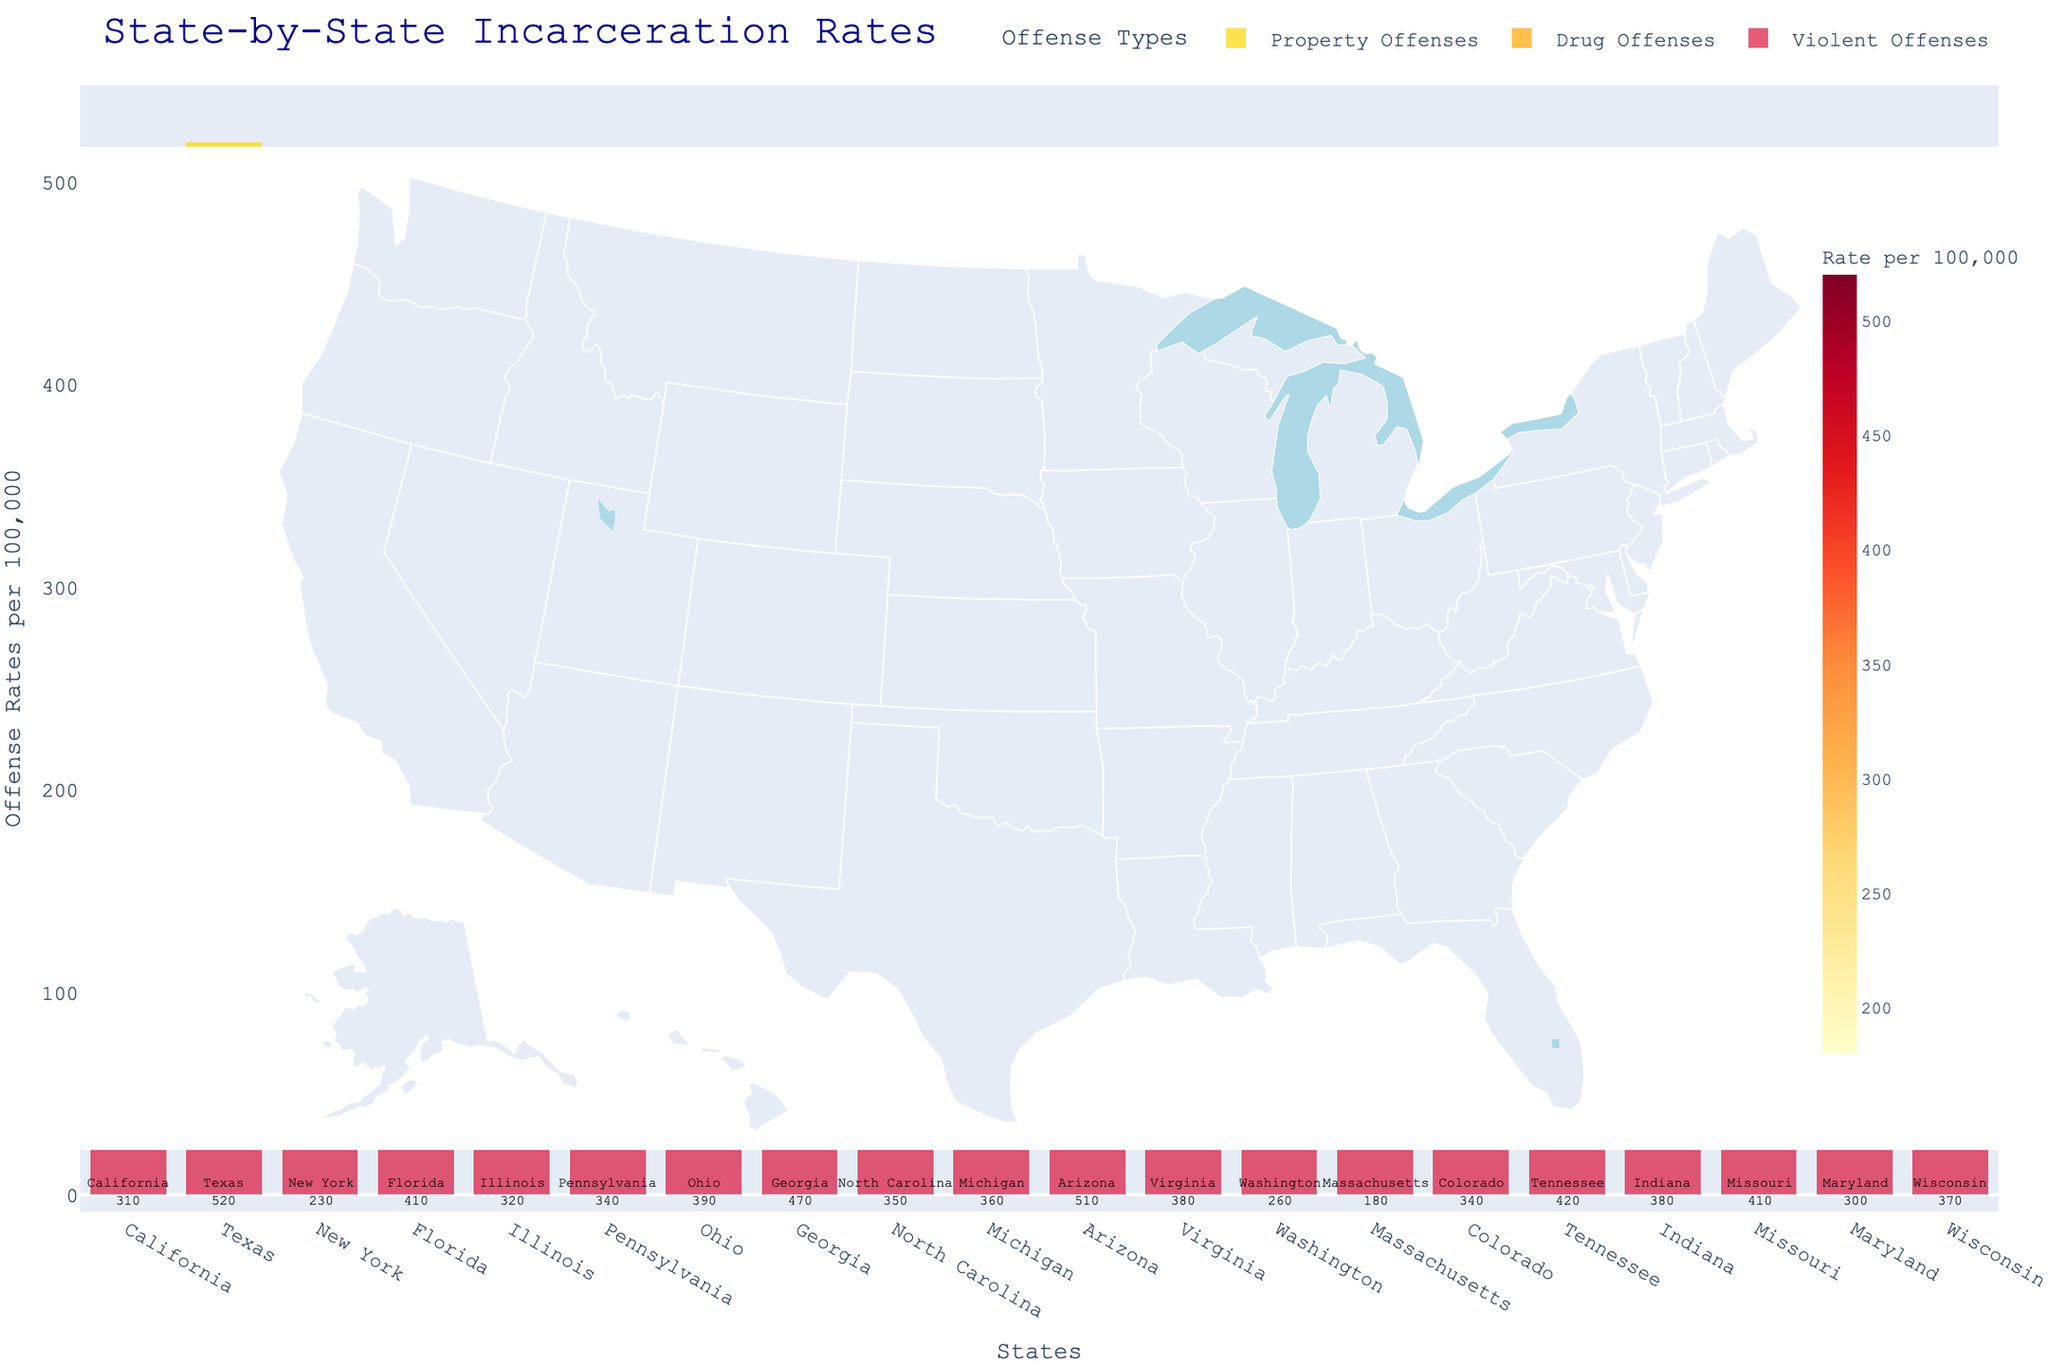What is the total incarceration rate for Texas? By viewing the figure, locate Texas and find the number associated with its total incarceration rate next to it.
Answer: 520 Which state has the lowest total incarceration rate? Scan through all the states listed in the figure and identify the one with the smallest number for total incarceration rate.
Answer: Massachusetts How much higher is the drug offense rate in Georgia compared to Massachusetts? Locate both Georgia and Massachusetts on the figure. Subtract the drug offense rate of Massachusetts (50) from that of Georgia (140).
Answer: 90 Which states have a total incarceration rate between 300 and 400? Identify states by examining their total incarceration rate figures and noting those that fall between 300 and 400.
Answer: California, Illinois, Pennsylvania, North Carolina, Michigan, Colorado, Virginia, Indiana, Maryland, Wisconsin Which state has the highest violent offense rate? Check the violent offense rates for all the states and identify the one with the highest rate.
Answer: Texas (or Arizona) What is the average property offense rate across all states? Add up all the property offense rates from each state and divide by the number of states (19).
Answer: (110+170+70+130+100+100+120+150+110+110+160+120+80+60+110+120+120+120+90+110) / 19 = 1930 / 19 = 101.6 What is the difference in total incarceration rate between Arizona and New York? Subtract the total incarceration rate of New York (230) from Arizona (510).
Answer: 280 Which state has the highest total incarceration rate for drug offenses? Compare the drug offense rates of each state and identify the one with the highest rate.
Answer: Texas (or Arizona) What is the total combined incarceration rate of violent, drug, and property offenses for California? Add the violent (120), drug (80), and property (110) offense rates of California.
Answer: 310 How do the property offense rates of Ohio and Virginia compare? Look at the property offense rates for Ohio (120) and Virginia (120). Compare them.
Answer: Equal 